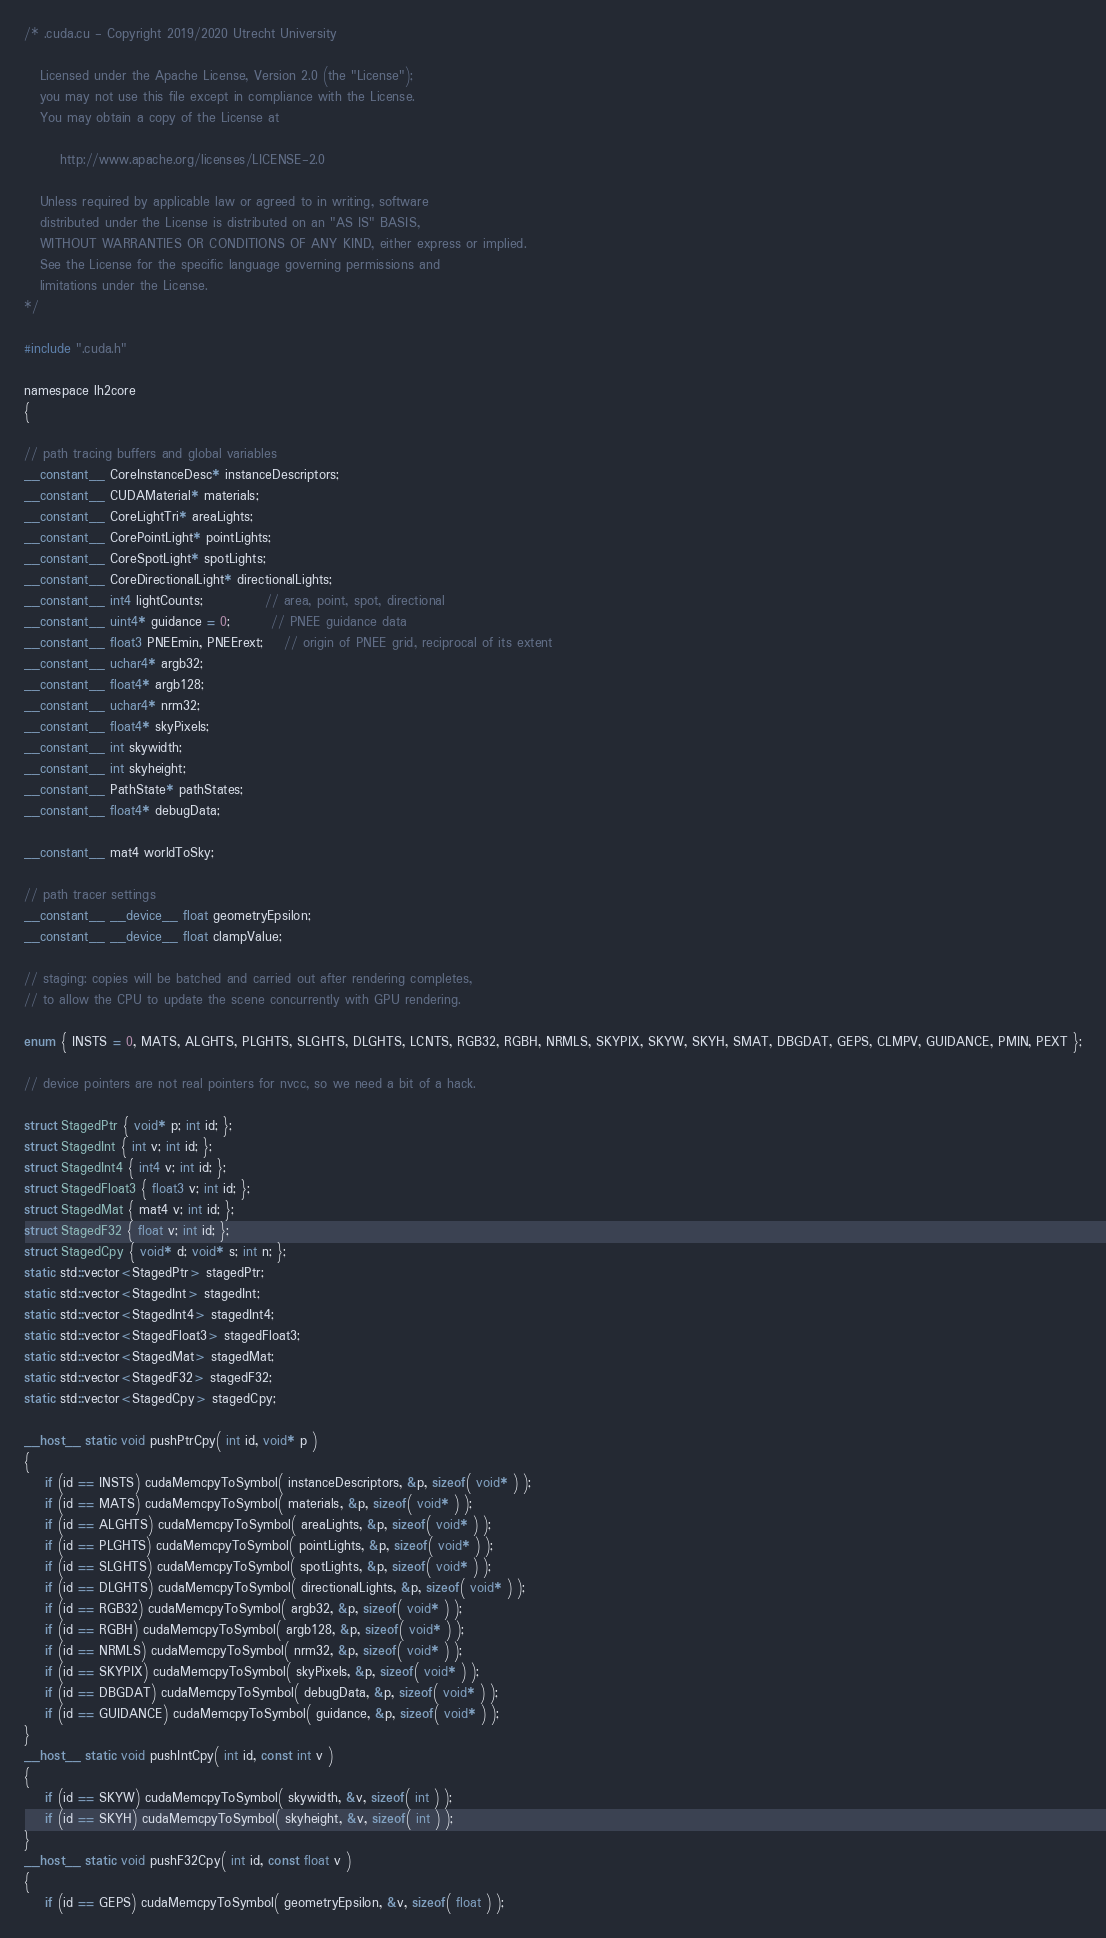Convert code to text. <code><loc_0><loc_0><loc_500><loc_500><_Cuda_>/* .cuda.cu - Copyright 2019/2020 Utrecht University

   Licensed under the Apache License, Version 2.0 (the "License");
   you may not use this file except in compliance with the License.
   You may obtain a copy of the License at

	   http://www.apache.org/licenses/LICENSE-2.0

   Unless required by applicable law or agreed to in writing, software
   distributed under the License is distributed on an "AS IS" BASIS,
   WITHOUT WARRANTIES OR CONDITIONS OF ANY KIND, either express or implied.
   See the License for the specific language governing permissions and
   limitations under the License.
*/

#include ".cuda.h"

namespace lh2core
{

// path tracing buffers and global variables
__constant__ CoreInstanceDesc* instanceDescriptors;
__constant__ CUDAMaterial* materials;
__constant__ CoreLightTri* areaLights;
__constant__ CorePointLight* pointLights;
__constant__ CoreSpotLight* spotLights;
__constant__ CoreDirectionalLight* directionalLights;
__constant__ int4 lightCounts;			// area, point, spot, directional
__constant__ uint4* guidance = 0;		// PNEE guidance data
__constant__ float3 PNEEmin, PNEErext;	// origin of PNEE grid, reciprocal of its extent
__constant__ uchar4* argb32;
__constant__ float4* argb128;
__constant__ uchar4* nrm32;
__constant__ float4* skyPixels;
__constant__ int skywidth;
__constant__ int skyheight;
__constant__ PathState* pathStates;
__constant__ float4* debugData;

__constant__ mat4 worldToSky;

// path tracer settings
__constant__ __device__ float geometryEpsilon;
__constant__ __device__ float clampValue;

// staging: copies will be batched and carried out after rendering completes, 
// to allow the CPU to update the scene concurrently with GPU rendering.

enum { INSTS = 0, MATS, ALGHTS, PLGHTS, SLGHTS, DLGHTS, LCNTS, RGB32, RGBH, NRMLS, SKYPIX, SKYW, SKYH, SMAT, DBGDAT, GEPS, CLMPV, GUIDANCE, PMIN, PEXT };

// device pointers are not real pointers for nvcc, so we need a bit of a hack.

struct StagedPtr { void* p; int id; };
struct StagedInt { int v; int id; };
struct StagedInt4 { int4 v; int id; };
struct StagedFloat3 { float3 v; int id; };
struct StagedMat { mat4 v; int id; };
struct StagedF32 { float v; int id; };
struct StagedCpy { void* d; void* s; int n; };
static std::vector<StagedPtr> stagedPtr;
static std::vector<StagedInt> stagedInt;
static std::vector<StagedInt4> stagedInt4;
static std::vector<StagedFloat3> stagedFloat3;
static std::vector<StagedMat> stagedMat;
static std::vector<StagedF32> stagedF32;
static std::vector<StagedCpy> stagedCpy;

__host__ static void pushPtrCpy( int id, void* p )
{
	if (id == INSTS) cudaMemcpyToSymbol( instanceDescriptors, &p, sizeof( void* ) );
	if (id == MATS) cudaMemcpyToSymbol( materials, &p, sizeof( void* ) );
	if (id == ALGHTS) cudaMemcpyToSymbol( areaLights, &p, sizeof( void* ) );
	if (id == PLGHTS) cudaMemcpyToSymbol( pointLights, &p, sizeof( void* ) );
	if (id == SLGHTS) cudaMemcpyToSymbol( spotLights, &p, sizeof( void* ) );
	if (id == DLGHTS) cudaMemcpyToSymbol( directionalLights, &p, sizeof( void* ) );
	if (id == RGB32) cudaMemcpyToSymbol( argb32, &p, sizeof( void* ) );
	if (id == RGBH) cudaMemcpyToSymbol( argb128, &p, sizeof( void* ) );
	if (id == NRMLS) cudaMemcpyToSymbol( nrm32, &p, sizeof( void* ) );
	if (id == SKYPIX) cudaMemcpyToSymbol( skyPixels, &p, sizeof( void* ) );
	if (id == DBGDAT) cudaMemcpyToSymbol( debugData, &p, sizeof( void* ) );
	if (id == GUIDANCE) cudaMemcpyToSymbol( guidance, &p, sizeof( void* ) );
}
__host__ static void pushIntCpy( int id, const int v )
{
	if (id == SKYW) cudaMemcpyToSymbol( skywidth, &v, sizeof( int ) );
	if (id == SKYH) cudaMemcpyToSymbol( skyheight, &v, sizeof( int ) );
}
__host__ static void pushF32Cpy( int id, const float v )
{
	if (id == GEPS) cudaMemcpyToSymbol( geometryEpsilon, &v, sizeof( float ) );</code> 